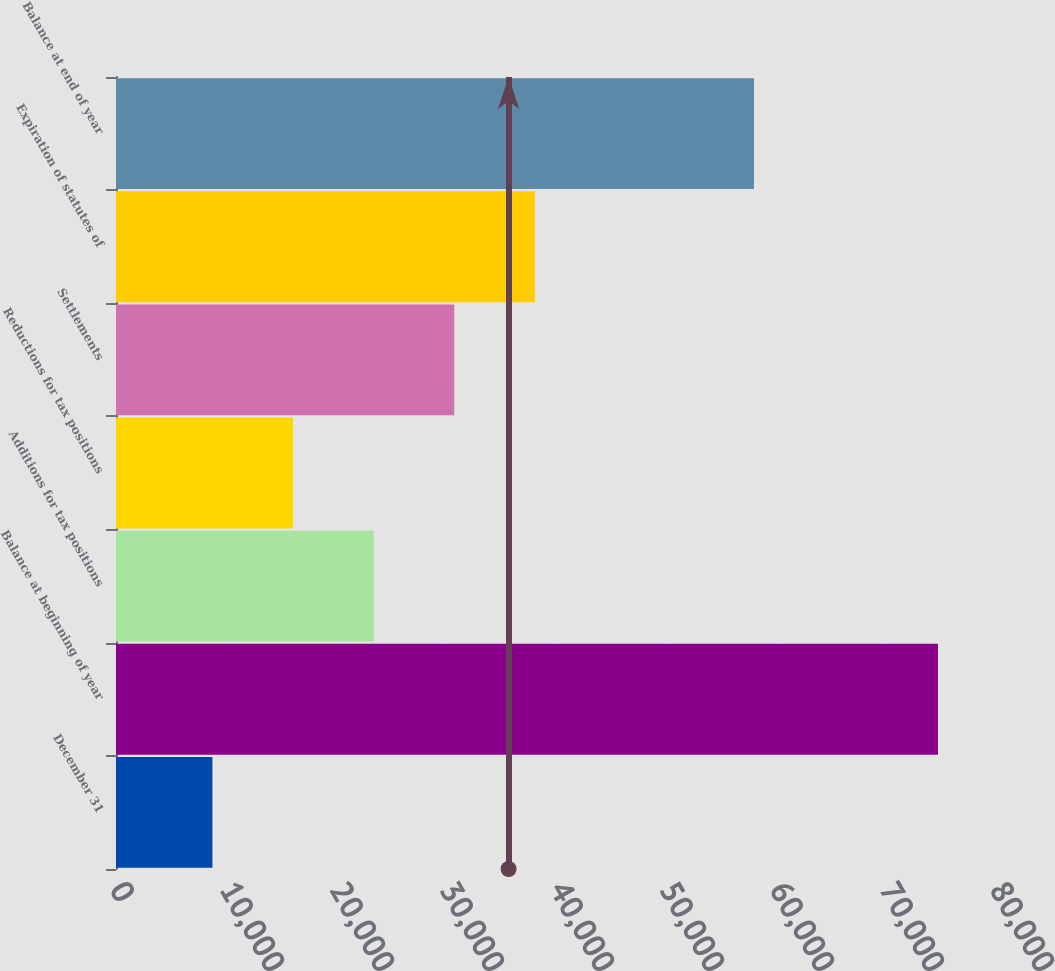Convert chart. <chart><loc_0><loc_0><loc_500><loc_500><bar_chart><fcel>December 31<fcel>Balance at beginning of year<fcel>Additions for tax positions<fcel>Reductions for tax positions<fcel>Settlements<fcel>Expiration of statutes of<fcel>Balance at end of year<nl><fcel>8764.8<fcel>74724<fcel>23422.4<fcel>16093.6<fcel>30751.2<fcel>38080<fcel>58000<nl></chart> 